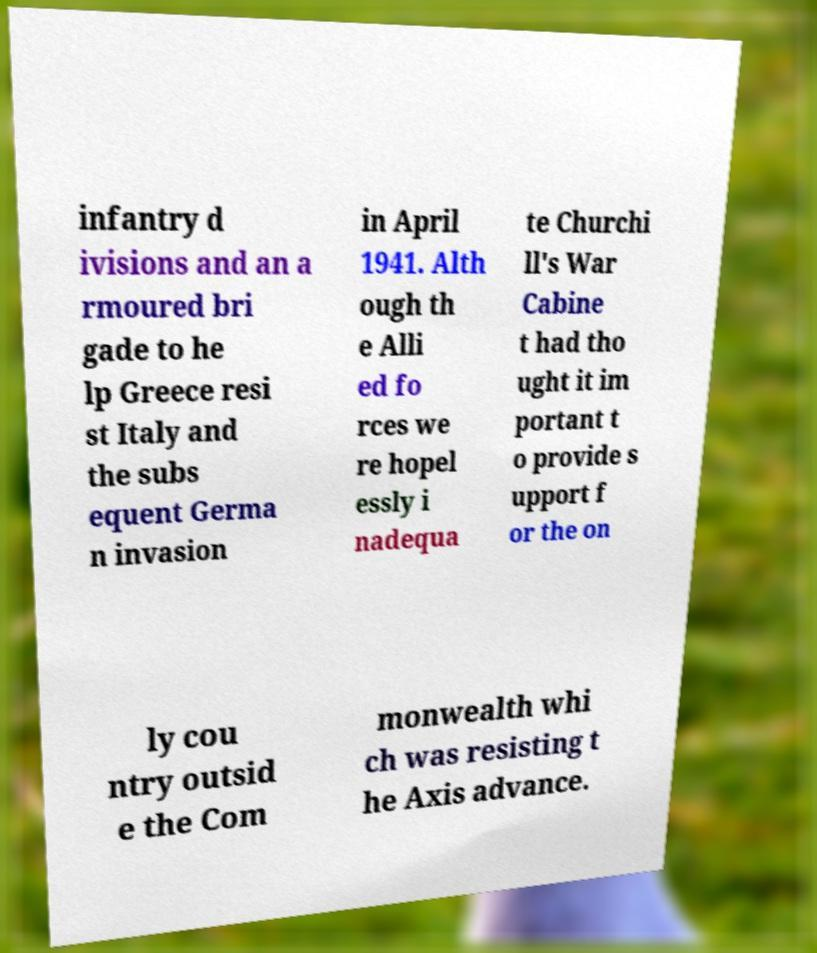Could you extract and type out the text from this image? infantry d ivisions and an a rmoured bri gade to he lp Greece resi st Italy and the subs equent Germa n invasion in April 1941. Alth ough th e Alli ed fo rces we re hopel essly i nadequa te Churchi ll's War Cabine t had tho ught it im portant t o provide s upport f or the on ly cou ntry outsid e the Com monwealth whi ch was resisting t he Axis advance. 